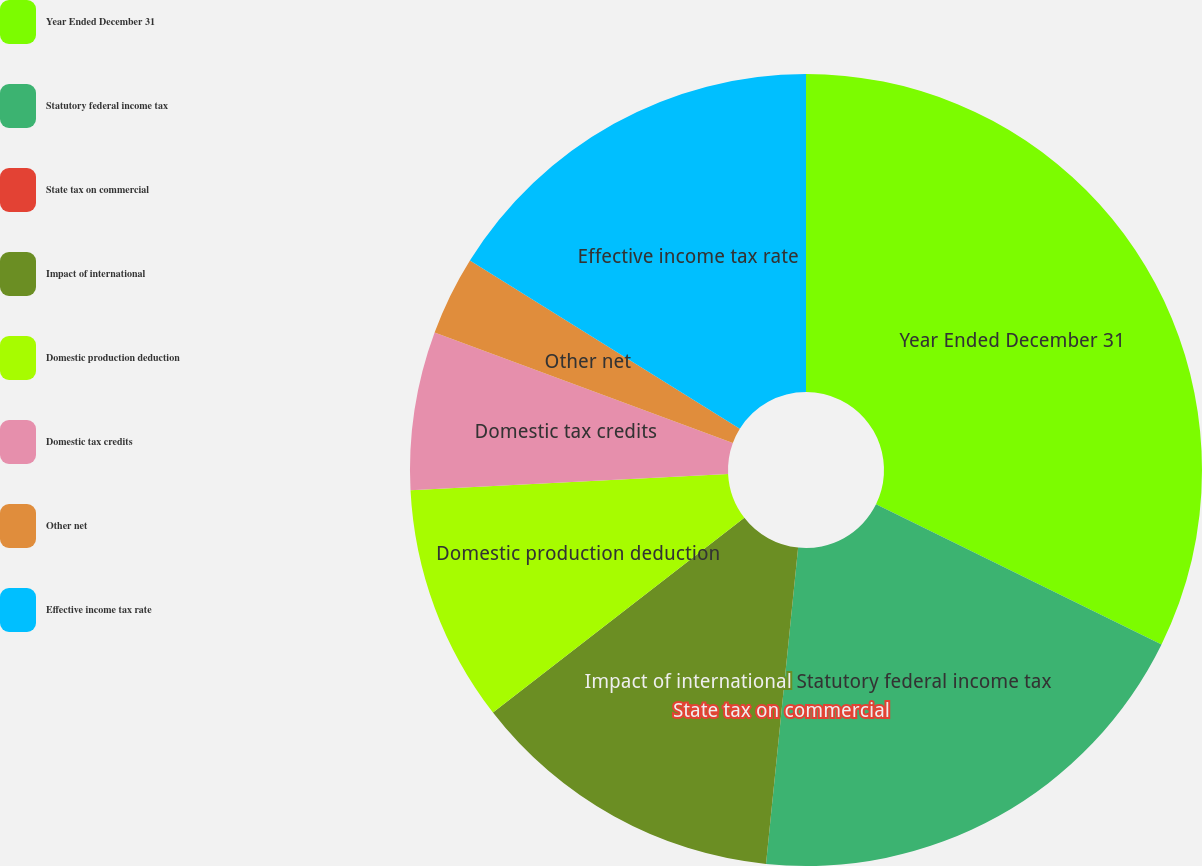<chart> <loc_0><loc_0><loc_500><loc_500><pie_chart><fcel>Year Ended December 31<fcel>Statutory federal income tax<fcel>State tax on commercial<fcel>Impact of international<fcel>Domestic production deduction<fcel>Domestic tax credits<fcel>Other net<fcel>Effective income tax rate<nl><fcel>32.26%<fcel>19.35%<fcel>0.0%<fcel>12.9%<fcel>9.68%<fcel>6.45%<fcel>3.23%<fcel>16.13%<nl></chart> 